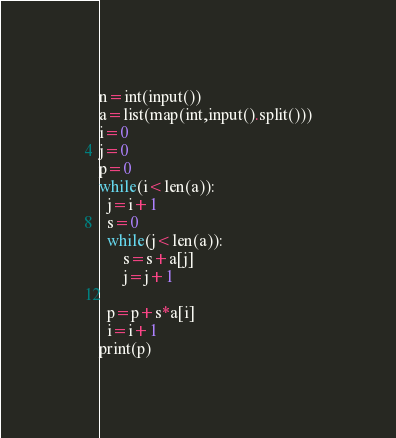Convert code to text. <code><loc_0><loc_0><loc_500><loc_500><_Python_>n=int(input())
a=list(map(int,input().split()))
i=0
j=0
p=0
while(i<len(a)):
  j=i+1
  s=0
  while(j<len(a)):
      s=s+a[j]
      j=j+1
  
  p=p+s*a[i]
  i=i+1
print(p)
</code> 